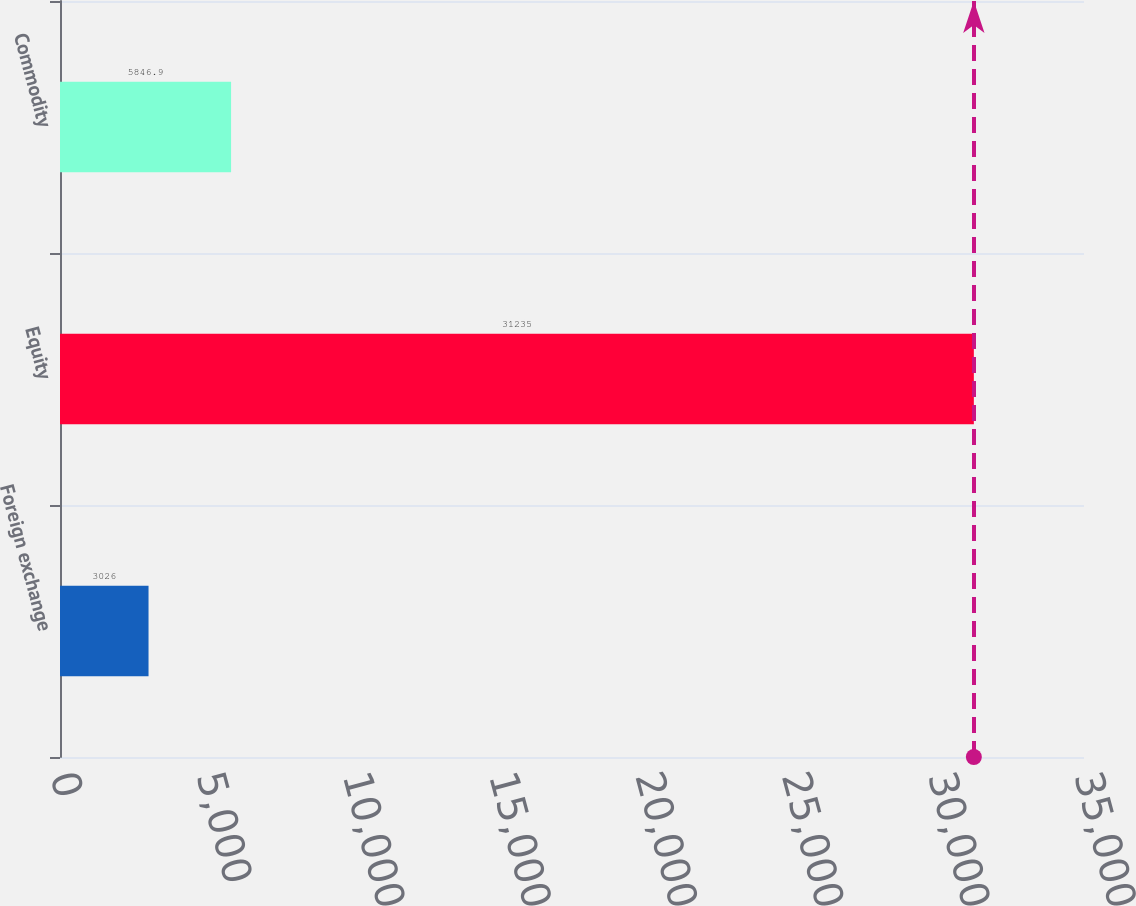<chart> <loc_0><loc_0><loc_500><loc_500><bar_chart><fcel>Foreign exchange<fcel>Equity<fcel>Commodity<nl><fcel>3026<fcel>31235<fcel>5846.9<nl></chart> 